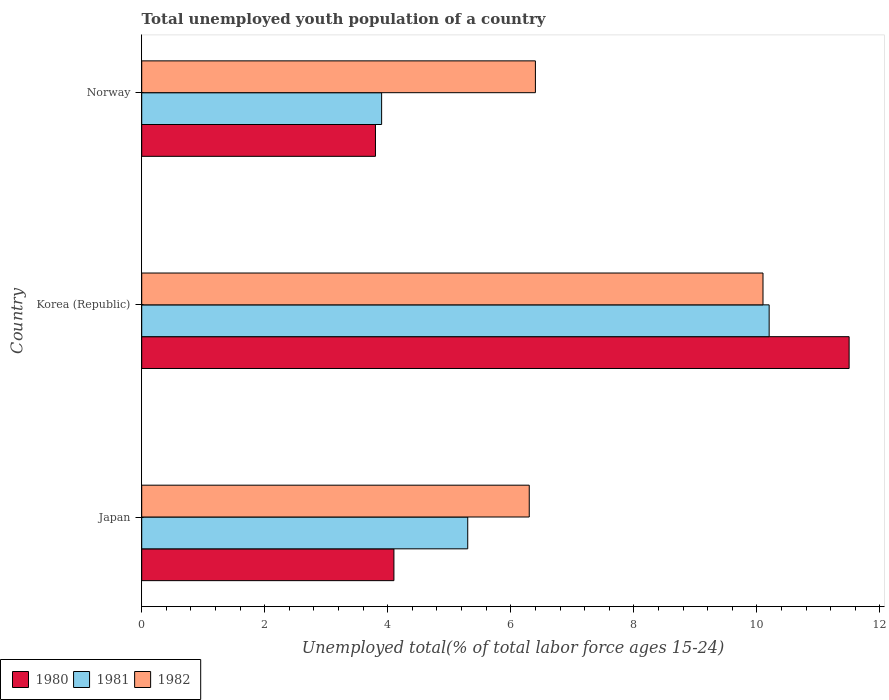Are the number of bars per tick equal to the number of legend labels?
Your answer should be compact. Yes. Are the number of bars on each tick of the Y-axis equal?
Your answer should be compact. Yes. How many bars are there on the 2nd tick from the top?
Make the answer very short. 3. How many bars are there on the 3rd tick from the bottom?
Ensure brevity in your answer.  3. What is the label of the 3rd group of bars from the top?
Your answer should be compact. Japan. What is the percentage of total unemployed youth population of a country in 1982 in Korea (Republic)?
Give a very brief answer. 10.1. Across all countries, what is the minimum percentage of total unemployed youth population of a country in 1981?
Offer a very short reply. 3.9. What is the total percentage of total unemployed youth population of a country in 1981 in the graph?
Provide a succinct answer. 19.4. What is the difference between the percentage of total unemployed youth population of a country in 1980 in Korea (Republic) and that in Norway?
Your answer should be very brief. 7.7. What is the difference between the percentage of total unemployed youth population of a country in 1982 in Japan and the percentage of total unemployed youth population of a country in 1981 in Norway?
Your answer should be very brief. 2.4. What is the average percentage of total unemployed youth population of a country in 1982 per country?
Give a very brief answer. 7.6. What is the difference between the percentage of total unemployed youth population of a country in 1980 and percentage of total unemployed youth population of a country in 1981 in Norway?
Give a very brief answer. -0.1. What is the ratio of the percentage of total unemployed youth population of a country in 1980 in Japan to that in Norway?
Ensure brevity in your answer.  1.08. Is the percentage of total unemployed youth population of a country in 1981 in Korea (Republic) less than that in Norway?
Offer a terse response. No. Is the difference between the percentage of total unemployed youth population of a country in 1980 in Japan and Norway greater than the difference between the percentage of total unemployed youth population of a country in 1981 in Japan and Norway?
Offer a very short reply. No. What is the difference between the highest and the second highest percentage of total unemployed youth population of a country in 1980?
Make the answer very short. 7.4. What is the difference between the highest and the lowest percentage of total unemployed youth population of a country in 1982?
Provide a succinct answer. 3.8. In how many countries, is the percentage of total unemployed youth population of a country in 1982 greater than the average percentage of total unemployed youth population of a country in 1982 taken over all countries?
Your answer should be compact. 1. Is the sum of the percentage of total unemployed youth population of a country in 1982 in Korea (Republic) and Norway greater than the maximum percentage of total unemployed youth population of a country in 1980 across all countries?
Keep it short and to the point. Yes. Is it the case that in every country, the sum of the percentage of total unemployed youth population of a country in 1980 and percentage of total unemployed youth population of a country in 1981 is greater than the percentage of total unemployed youth population of a country in 1982?
Offer a terse response. Yes. How many countries are there in the graph?
Ensure brevity in your answer.  3. Are the values on the major ticks of X-axis written in scientific E-notation?
Your answer should be compact. No. Does the graph contain any zero values?
Offer a very short reply. No. How are the legend labels stacked?
Offer a terse response. Horizontal. What is the title of the graph?
Provide a short and direct response. Total unemployed youth population of a country. What is the label or title of the X-axis?
Provide a succinct answer. Unemployed total(% of total labor force ages 15-24). What is the label or title of the Y-axis?
Your answer should be very brief. Country. What is the Unemployed total(% of total labor force ages 15-24) in 1980 in Japan?
Provide a succinct answer. 4.1. What is the Unemployed total(% of total labor force ages 15-24) of 1981 in Japan?
Offer a very short reply. 5.3. What is the Unemployed total(% of total labor force ages 15-24) in 1982 in Japan?
Give a very brief answer. 6.3. What is the Unemployed total(% of total labor force ages 15-24) of 1981 in Korea (Republic)?
Your answer should be very brief. 10.2. What is the Unemployed total(% of total labor force ages 15-24) in 1982 in Korea (Republic)?
Your answer should be very brief. 10.1. What is the Unemployed total(% of total labor force ages 15-24) of 1980 in Norway?
Make the answer very short. 3.8. What is the Unemployed total(% of total labor force ages 15-24) in 1981 in Norway?
Your answer should be compact. 3.9. What is the Unemployed total(% of total labor force ages 15-24) of 1982 in Norway?
Your response must be concise. 6.4. Across all countries, what is the maximum Unemployed total(% of total labor force ages 15-24) in 1981?
Offer a terse response. 10.2. Across all countries, what is the maximum Unemployed total(% of total labor force ages 15-24) in 1982?
Your answer should be compact. 10.1. Across all countries, what is the minimum Unemployed total(% of total labor force ages 15-24) in 1980?
Ensure brevity in your answer.  3.8. Across all countries, what is the minimum Unemployed total(% of total labor force ages 15-24) of 1981?
Ensure brevity in your answer.  3.9. Across all countries, what is the minimum Unemployed total(% of total labor force ages 15-24) in 1982?
Make the answer very short. 6.3. What is the total Unemployed total(% of total labor force ages 15-24) of 1980 in the graph?
Your answer should be compact. 19.4. What is the total Unemployed total(% of total labor force ages 15-24) in 1981 in the graph?
Provide a short and direct response. 19.4. What is the total Unemployed total(% of total labor force ages 15-24) of 1982 in the graph?
Your answer should be compact. 22.8. What is the difference between the Unemployed total(% of total labor force ages 15-24) in 1980 in Japan and that in Korea (Republic)?
Provide a succinct answer. -7.4. What is the difference between the Unemployed total(% of total labor force ages 15-24) of 1981 in Japan and that in Korea (Republic)?
Provide a short and direct response. -4.9. What is the difference between the Unemployed total(% of total labor force ages 15-24) of 1982 in Japan and that in Korea (Republic)?
Your response must be concise. -3.8. What is the difference between the Unemployed total(% of total labor force ages 15-24) in 1980 in Japan and that in Norway?
Provide a short and direct response. 0.3. What is the difference between the Unemployed total(% of total labor force ages 15-24) of 1980 in Korea (Republic) and that in Norway?
Your answer should be compact. 7.7. What is the difference between the Unemployed total(% of total labor force ages 15-24) in 1980 in Japan and the Unemployed total(% of total labor force ages 15-24) in 1981 in Korea (Republic)?
Offer a terse response. -6.1. What is the difference between the Unemployed total(% of total labor force ages 15-24) in 1981 in Japan and the Unemployed total(% of total labor force ages 15-24) in 1982 in Norway?
Ensure brevity in your answer.  -1.1. What is the difference between the Unemployed total(% of total labor force ages 15-24) of 1980 in Korea (Republic) and the Unemployed total(% of total labor force ages 15-24) of 1981 in Norway?
Offer a terse response. 7.6. What is the difference between the Unemployed total(% of total labor force ages 15-24) in 1980 in Korea (Republic) and the Unemployed total(% of total labor force ages 15-24) in 1982 in Norway?
Offer a terse response. 5.1. What is the difference between the Unemployed total(% of total labor force ages 15-24) in 1981 in Korea (Republic) and the Unemployed total(% of total labor force ages 15-24) in 1982 in Norway?
Keep it short and to the point. 3.8. What is the average Unemployed total(% of total labor force ages 15-24) in 1980 per country?
Keep it short and to the point. 6.47. What is the average Unemployed total(% of total labor force ages 15-24) in 1981 per country?
Ensure brevity in your answer.  6.47. What is the difference between the Unemployed total(% of total labor force ages 15-24) in 1980 and Unemployed total(% of total labor force ages 15-24) in 1982 in Japan?
Provide a succinct answer. -2.2. What is the difference between the Unemployed total(% of total labor force ages 15-24) of 1981 and Unemployed total(% of total labor force ages 15-24) of 1982 in Japan?
Provide a succinct answer. -1. What is the difference between the Unemployed total(% of total labor force ages 15-24) in 1980 and Unemployed total(% of total labor force ages 15-24) in 1982 in Korea (Republic)?
Ensure brevity in your answer.  1.4. What is the difference between the Unemployed total(% of total labor force ages 15-24) in 1980 and Unemployed total(% of total labor force ages 15-24) in 1982 in Norway?
Ensure brevity in your answer.  -2.6. What is the ratio of the Unemployed total(% of total labor force ages 15-24) of 1980 in Japan to that in Korea (Republic)?
Provide a succinct answer. 0.36. What is the ratio of the Unemployed total(% of total labor force ages 15-24) of 1981 in Japan to that in Korea (Republic)?
Provide a succinct answer. 0.52. What is the ratio of the Unemployed total(% of total labor force ages 15-24) of 1982 in Japan to that in Korea (Republic)?
Ensure brevity in your answer.  0.62. What is the ratio of the Unemployed total(% of total labor force ages 15-24) in 1980 in Japan to that in Norway?
Ensure brevity in your answer.  1.08. What is the ratio of the Unemployed total(% of total labor force ages 15-24) in 1981 in Japan to that in Norway?
Offer a very short reply. 1.36. What is the ratio of the Unemployed total(% of total labor force ages 15-24) of 1982 in Japan to that in Norway?
Make the answer very short. 0.98. What is the ratio of the Unemployed total(% of total labor force ages 15-24) in 1980 in Korea (Republic) to that in Norway?
Give a very brief answer. 3.03. What is the ratio of the Unemployed total(% of total labor force ages 15-24) in 1981 in Korea (Republic) to that in Norway?
Provide a short and direct response. 2.62. What is the ratio of the Unemployed total(% of total labor force ages 15-24) of 1982 in Korea (Republic) to that in Norway?
Provide a succinct answer. 1.58. What is the difference between the highest and the second highest Unemployed total(% of total labor force ages 15-24) of 1980?
Your answer should be compact. 7.4. What is the difference between the highest and the lowest Unemployed total(% of total labor force ages 15-24) in 1980?
Your answer should be very brief. 7.7. 